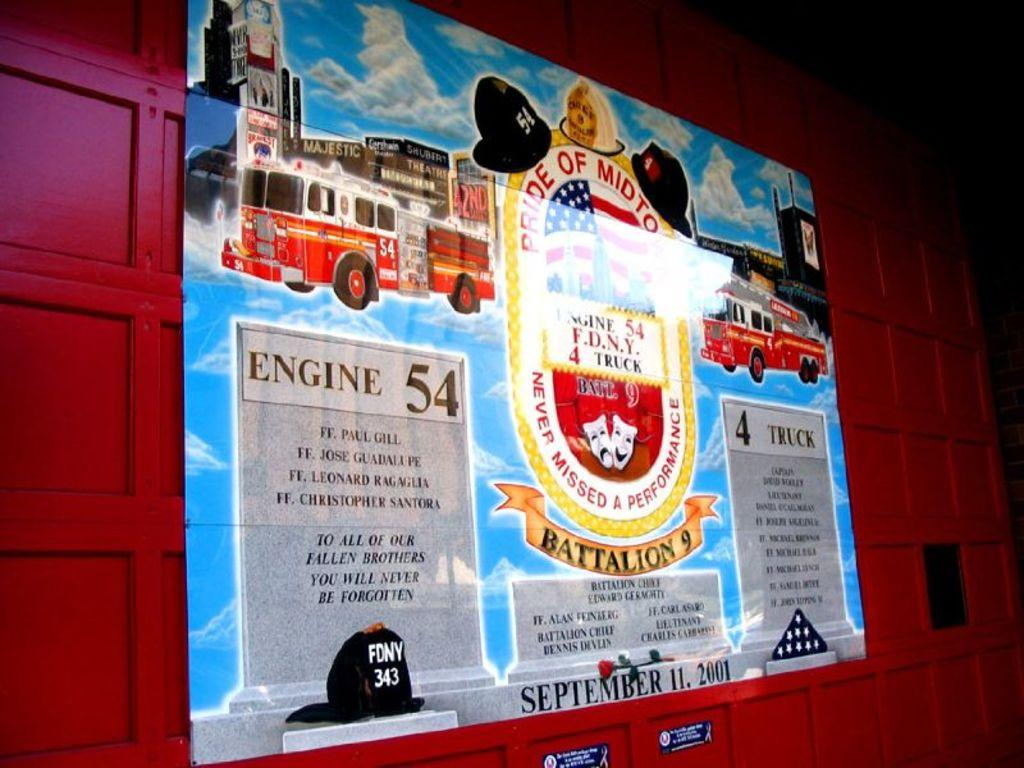<image>
Describe the image concisely. a poster on a wall that says 'engine 54' on it 